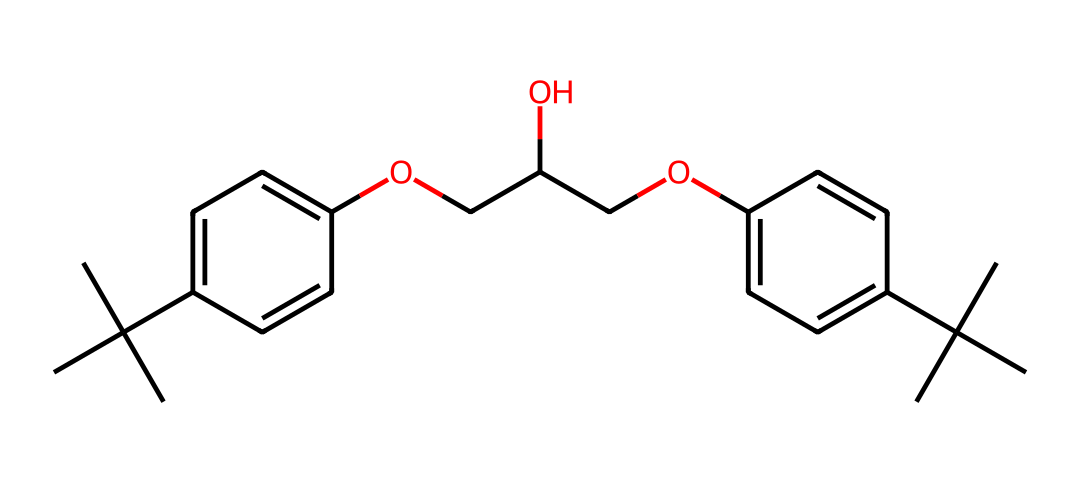How many carbon atoms are present in this chemical? To determine the number of carbon atoms, we can count each 'C' atom represented in the SMILES notation. The notation indicates several distinct carbon groups. Upon counting, there are 22 carbon atoms in total.
Answer: 22 What functional group is present in the chemical structure? The presence of the 'O' indicates that there are ether (or alcohol) groups in the structure. In this case, the 'OCC' segment suggests a potential ether linkage, while the alcohol functionality is indicated by the 'O' connected to 'C' which is connected to 'OH'.
Answer: ether What is the degree of unsaturation in this molecule? The degree of unsaturation can be calculated by using the formula: (2C + 2 - H)/2. Here, C is the count of carbon atoms and H is the assumed hydrogen count based on carbon saturation. This compound possesses 6 degrees of unsaturation, indicating 6 double bonds or rings.
Answer: 6 Does this chemical contain any aromatic rings? To check for aromaticity, we can observe the 'C1=CC=C' segments which denote cyclic structures with alternating double bonds, confirming the presence of aromatic rings. There are two such aromatic rings in the compound.
Answer: two What type of biochemical application is indicated by this structure? This compound’s functional groups, particularly the presence of ether and alcohol functionalities, suggest that it may be used in adhesives, specifically for wind turbine blades. This is due to its ability to form strong bonds under various conditions.
Answer: adhesives 